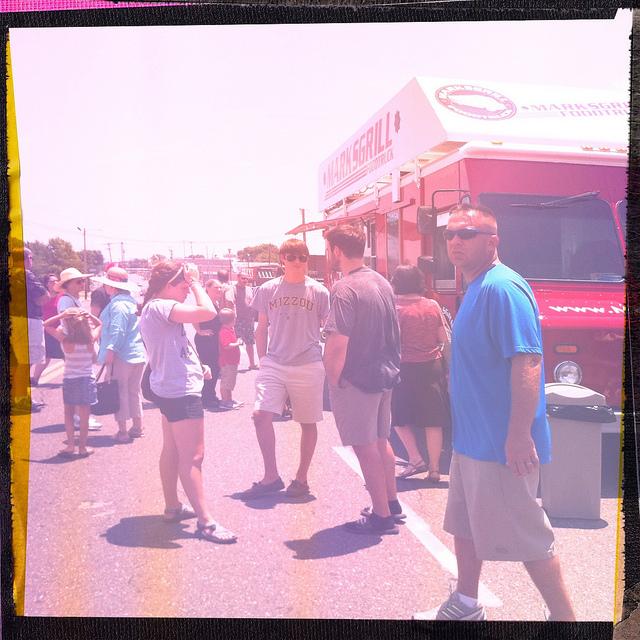Has this photo been filtered?
Be succinct. Yes. How many people are in the picture?
Quick response, please. 12. What is the truck in the picture called?
Be succinct. Food truck. Is the photo in color or black and white?
Be succinct. Color. How old is this image?
Be succinct. 2 years. 